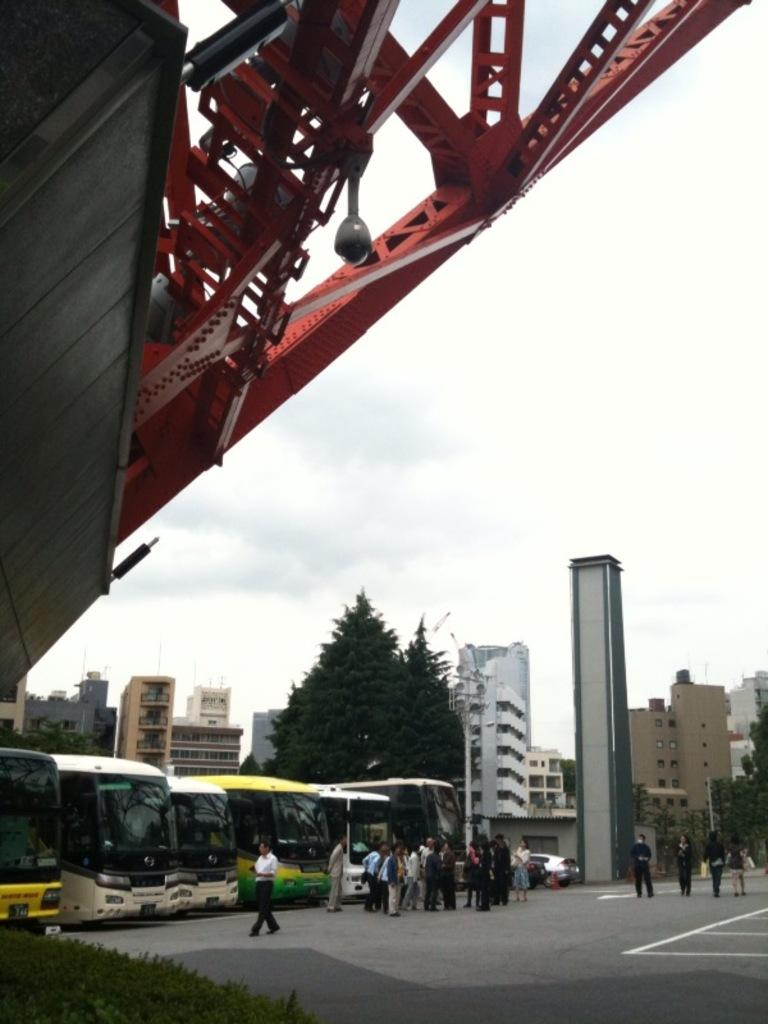Who or what can be seen in the image? There are people in the image. What type of vehicles are on the road in the image? There are buses on the road in the image. What can be seen in the background of the image? There are buildings, trees, and the sky visible in the background of the image. What architectural feature is present at the top of the image? There is a bridge at the top of the image. What type of pen is being used to write on the board in the image? There is no pen or board present in the image. 